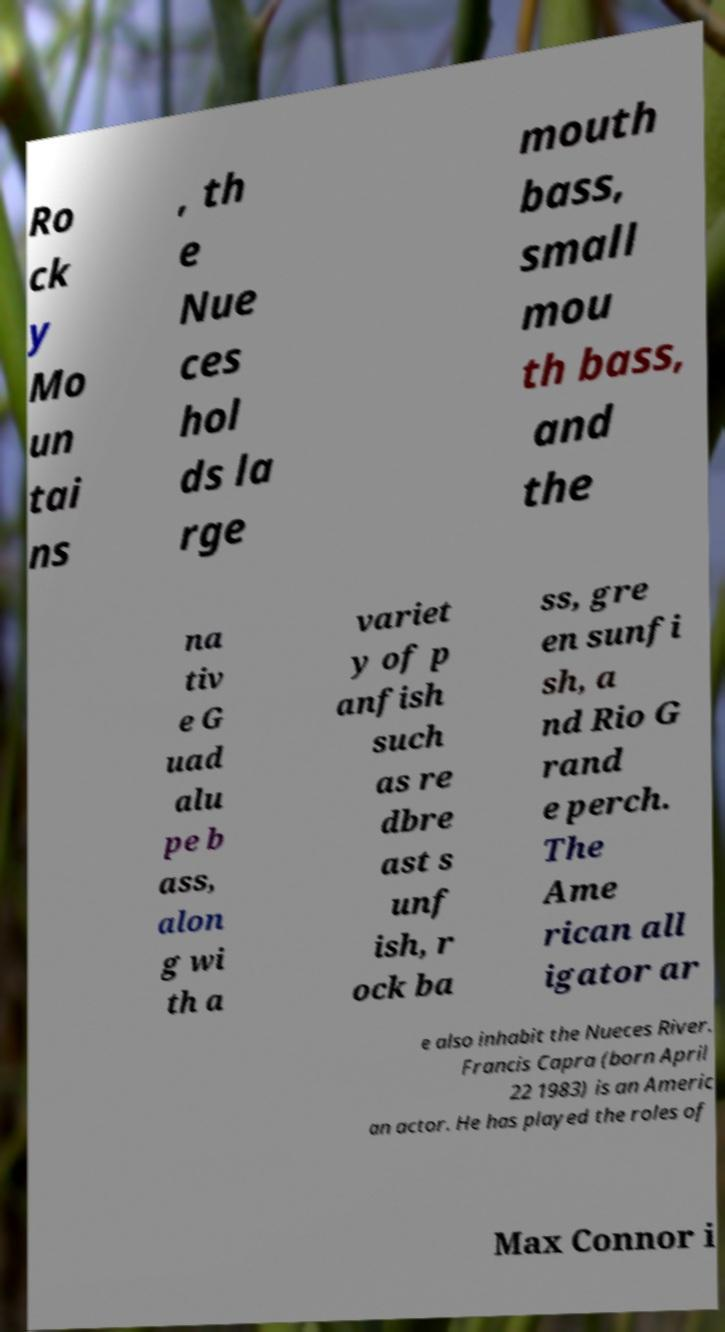Could you assist in decoding the text presented in this image and type it out clearly? Ro ck y Mo un tai ns , th e Nue ces hol ds la rge mouth bass, small mou th bass, and the na tiv e G uad alu pe b ass, alon g wi th a variet y of p anfish such as re dbre ast s unf ish, r ock ba ss, gre en sunfi sh, a nd Rio G rand e perch. The Ame rican all igator ar e also inhabit the Nueces River. Francis Capra (born April 22 1983) is an Americ an actor. He has played the roles of Max Connor i 